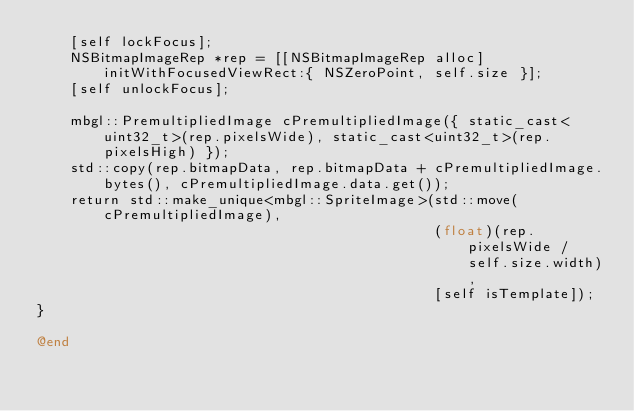Convert code to text. <code><loc_0><loc_0><loc_500><loc_500><_ObjectiveC_>    [self lockFocus];
    NSBitmapImageRep *rep = [[NSBitmapImageRep alloc] initWithFocusedViewRect:{ NSZeroPoint, self.size }];
    [self unlockFocus];

    mbgl::PremultipliedImage cPremultipliedImage({ static_cast<uint32_t>(rep.pixelsWide), static_cast<uint32_t>(rep.pixelsHigh) });
    std::copy(rep.bitmapData, rep.bitmapData + cPremultipliedImage.bytes(), cPremultipliedImage.data.get());
    return std::make_unique<mbgl::SpriteImage>(std::move(cPremultipliedImage),
                                               (float)(rep.pixelsWide / self.size.width),
                                               [self isTemplate]);
}

@end
</code> 